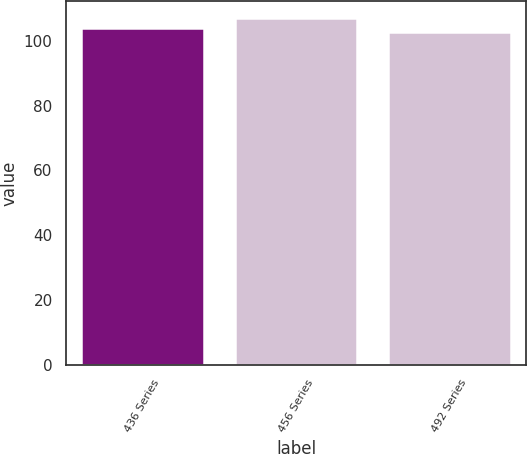<chart> <loc_0><loc_0><loc_500><loc_500><bar_chart><fcel>436 Series<fcel>456 Series<fcel>492 Series<nl><fcel>103.86<fcel>107<fcel>102.88<nl></chart> 